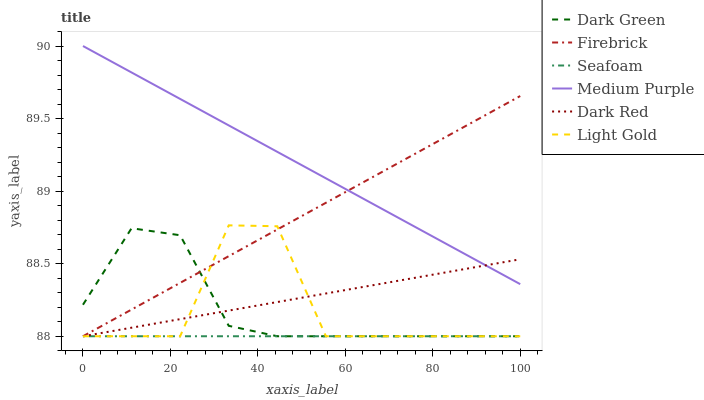Does Seafoam have the minimum area under the curve?
Answer yes or no. Yes. Does Medium Purple have the maximum area under the curve?
Answer yes or no. Yes. Does Firebrick have the minimum area under the curve?
Answer yes or no. No. Does Firebrick have the maximum area under the curve?
Answer yes or no. No. Is Seafoam the smoothest?
Answer yes or no. Yes. Is Light Gold the roughest?
Answer yes or no. Yes. Is Firebrick the smoothest?
Answer yes or no. No. Is Firebrick the roughest?
Answer yes or no. No. Does Dark Red have the lowest value?
Answer yes or no. Yes. Does Medium Purple have the lowest value?
Answer yes or no. No. Does Medium Purple have the highest value?
Answer yes or no. Yes. Does Firebrick have the highest value?
Answer yes or no. No. Is Dark Green less than Medium Purple?
Answer yes or no. Yes. Is Medium Purple greater than Seafoam?
Answer yes or no. Yes. Does Dark Red intersect Firebrick?
Answer yes or no. Yes. Is Dark Red less than Firebrick?
Answer yes or no. No. Is Dark Red greater than Firebrick?
Answer yes or no. No. Does Dark Green intersect Medium Purple?
Answer yes or no. No. 